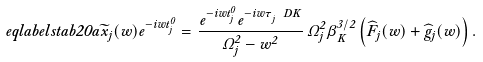Convert formula to latex. <formula><loc_0><loc_0><loc_500><loc_500>\ e q l a b e l { s t a b 2 0 a } \widetilde { x } _ { j } ( w ) e ^ { - i w t _ { j } ^ { 0 } } = \frac { e ^ { - i w t _ { j } ^ { 0 } } e ^ { - i w \tau _ { j } ^ { \ } D K } } { \Omega _ { j } ^ { 2 } - w ^ { 2 } } \, \Omega _ { j } ^ { 2 } \beta _ { K } ^ { 3 / 2 } \left ( \widehat { F } _ { j } ( w ) + \widehat { g } _ { j } ( w ) \right ) .</formula> 